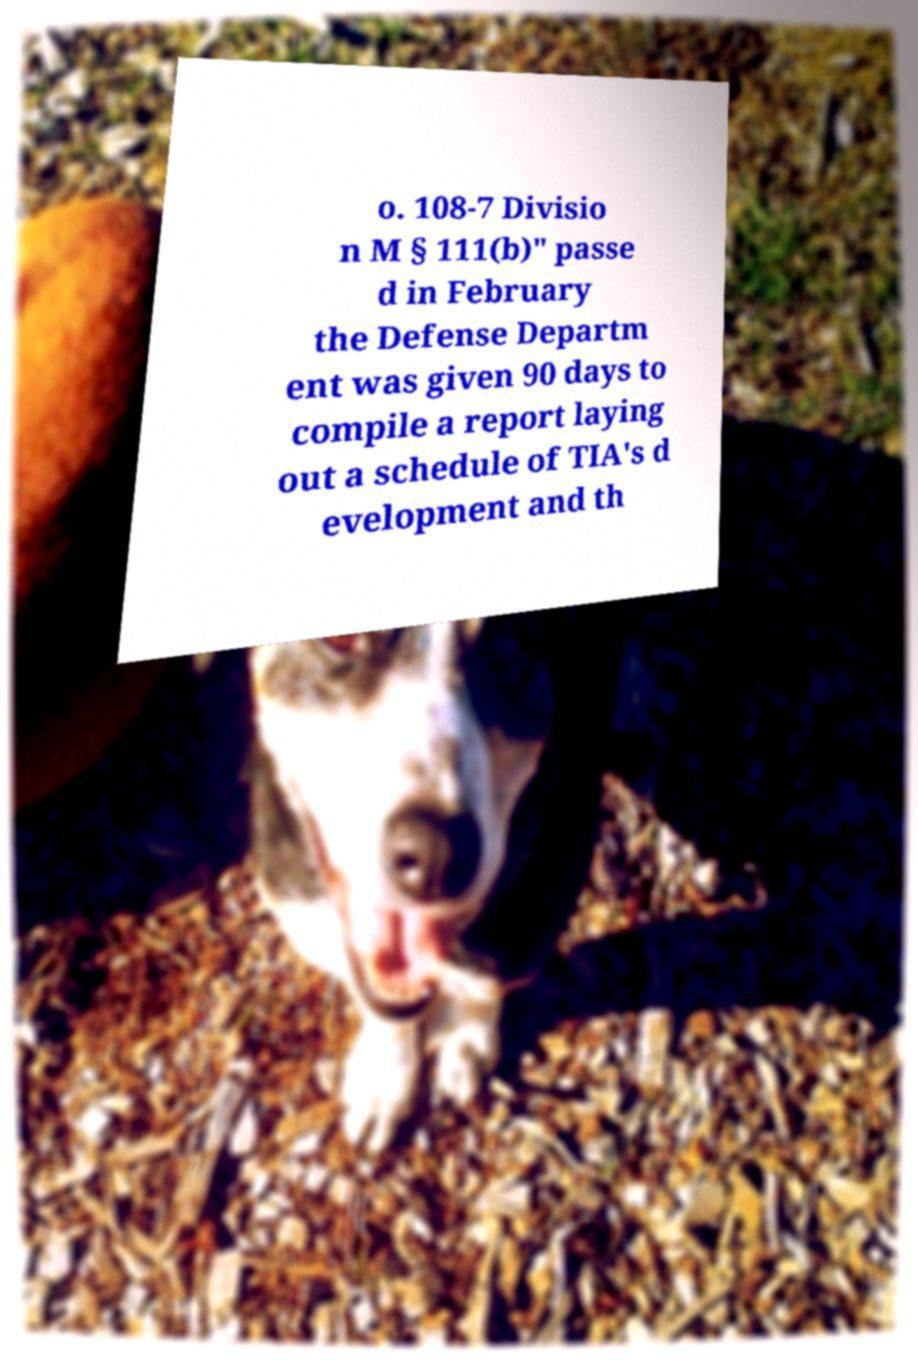Can you accurately transcribe the text from the provided image for me? o. 108-7 Divisio n M § 111(b)" passe d in February the Defense Departm ent was given 90 days to compile a report laying out a schedule of TIA's d evelopment and th 